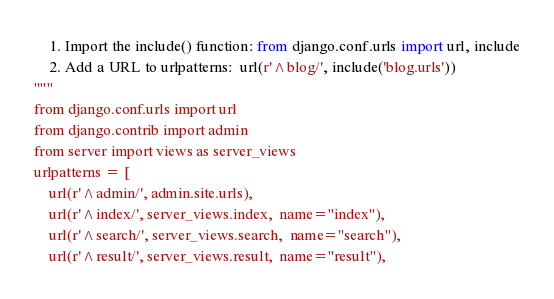<code> <loc_0><loc_0><loc_500><loc_500><_Python_>    1. Import the include() function: from django.conf.urls import url, include
    2. Add a URL to urlpatterns:  url(r'^blog/', include('blog.urls'))
"""
from django.conf.urls import url
from django.contrib import admin
from server import views as server_views
urlpatterns = [
    url(r'^admin/', admin.site.urls),
    url(r'^index/', server_views.index,  name="index"),
    url(r'^search/', server_views.search,  name="search"),
    url(r'^result/', server_views.result,  name="result"),</code> 